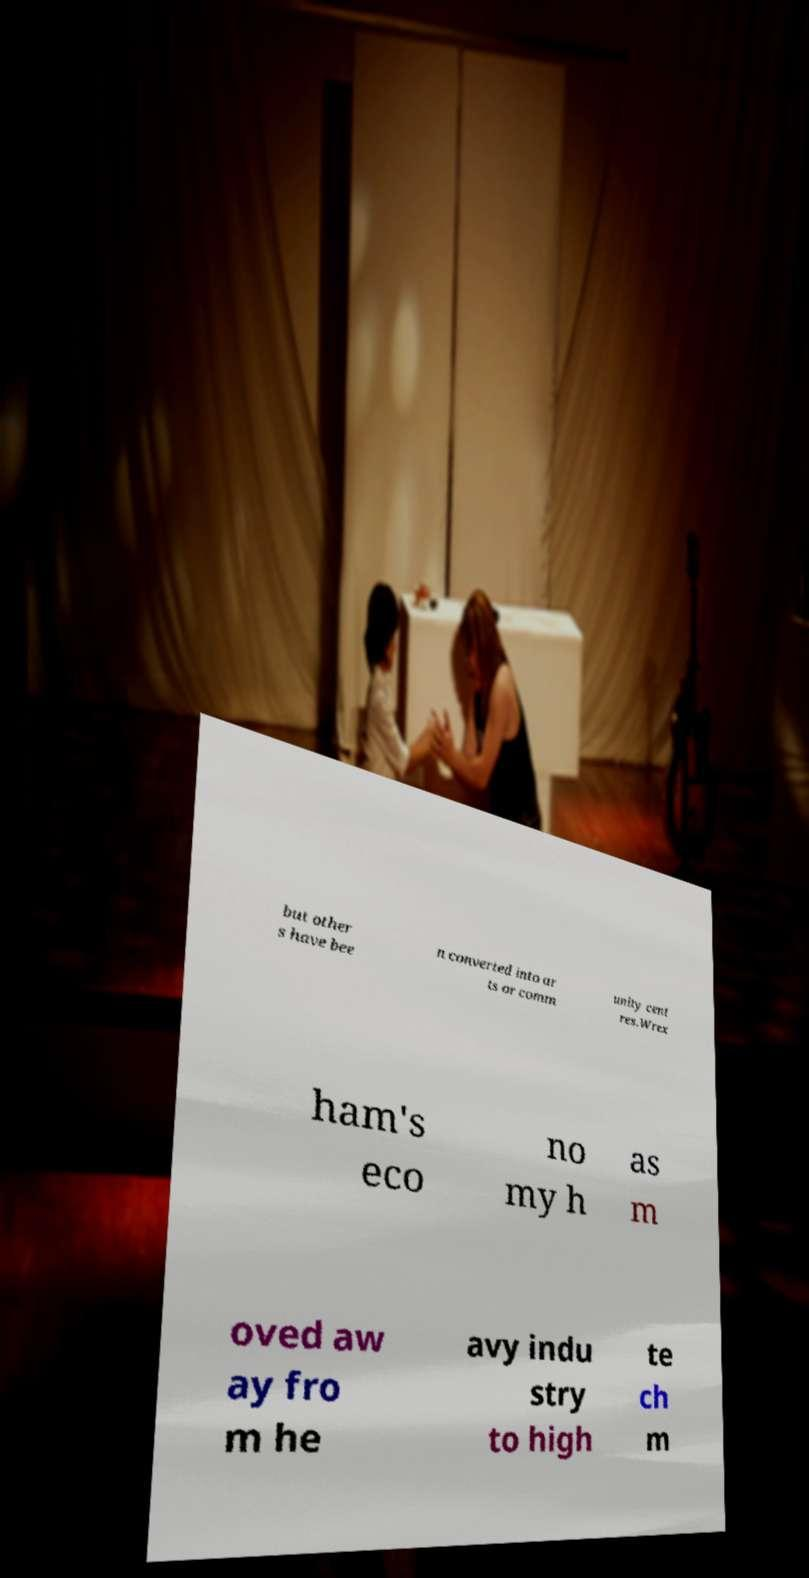There's text embedded in this image that I need extracted. Can you transcribe it verbatim? but other s have bee n converted into ar ts or comm unity cent res.Wrex ham's eco no my h as m oved aw ay fro m he avy indu stry to high te ch m 